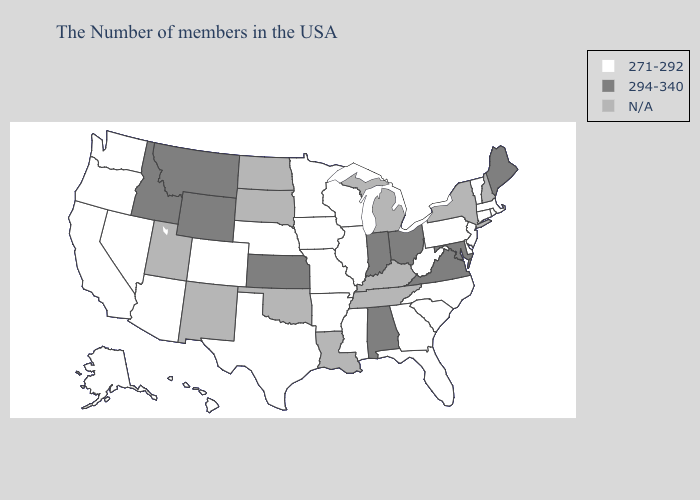How many symbols are there in the legend?
Short answer required. 3. Does the first symbol in the legend represent the smallest category?
Be succinct. Yes. Among the states that border Iowa , which have the highest value?
Write a very short answer. Wisconsin, Illinois, Missouri, Minnesota, Nebraska. Name the states that have a value in the range 294-340?
Keep it brief. Maine, Maryland, Virginia, Ohio, Indiana, Alabama, Kansas, Wyoming, Montana, Idaho. Does Massachusetts have the highest value in the Northeast?
Be succinct. No. What is the value of Vermont?
Answer briefly. 271-292. What is the highest value in states that border Wisconsin?
Give a very brief answer. 271-292. Name the states that have a value in the range 294-340?
Give a very brief answer. Maine, Maryland, Virginia, Ohio, Indiana, Alabama, Kansas, Wyoming, Montana, Idaho. Name the states that have a value in the range 294-340?
Be succinct. Maine, Maryland, Virginia, Ohio, Indiana, Alabama, Kansas, Wyoming, Montana, Idaho. Does Maryland have the highest value in the USA?
Answer briefly. Yes. What is the value of Utah?
Concise answer only. N/A. Does Massachusetts have the lowest value in the USA?
Quick response, please. Yes. Name the states that have a value in the range N/A?
Write a very short answer. New Hampshire, New York, Michigan, Kentucky, Tennessee, Louisiana, Oklahoma, South Dakota, North Dakota, New Mexico, Utah. Name the states that have a value in the range 294-340?
Answer briefly. Maine, Maryland, Virginia, Ohio, Indiana, Alabama, Kansas, Wyoming, Montana, Idaho. 